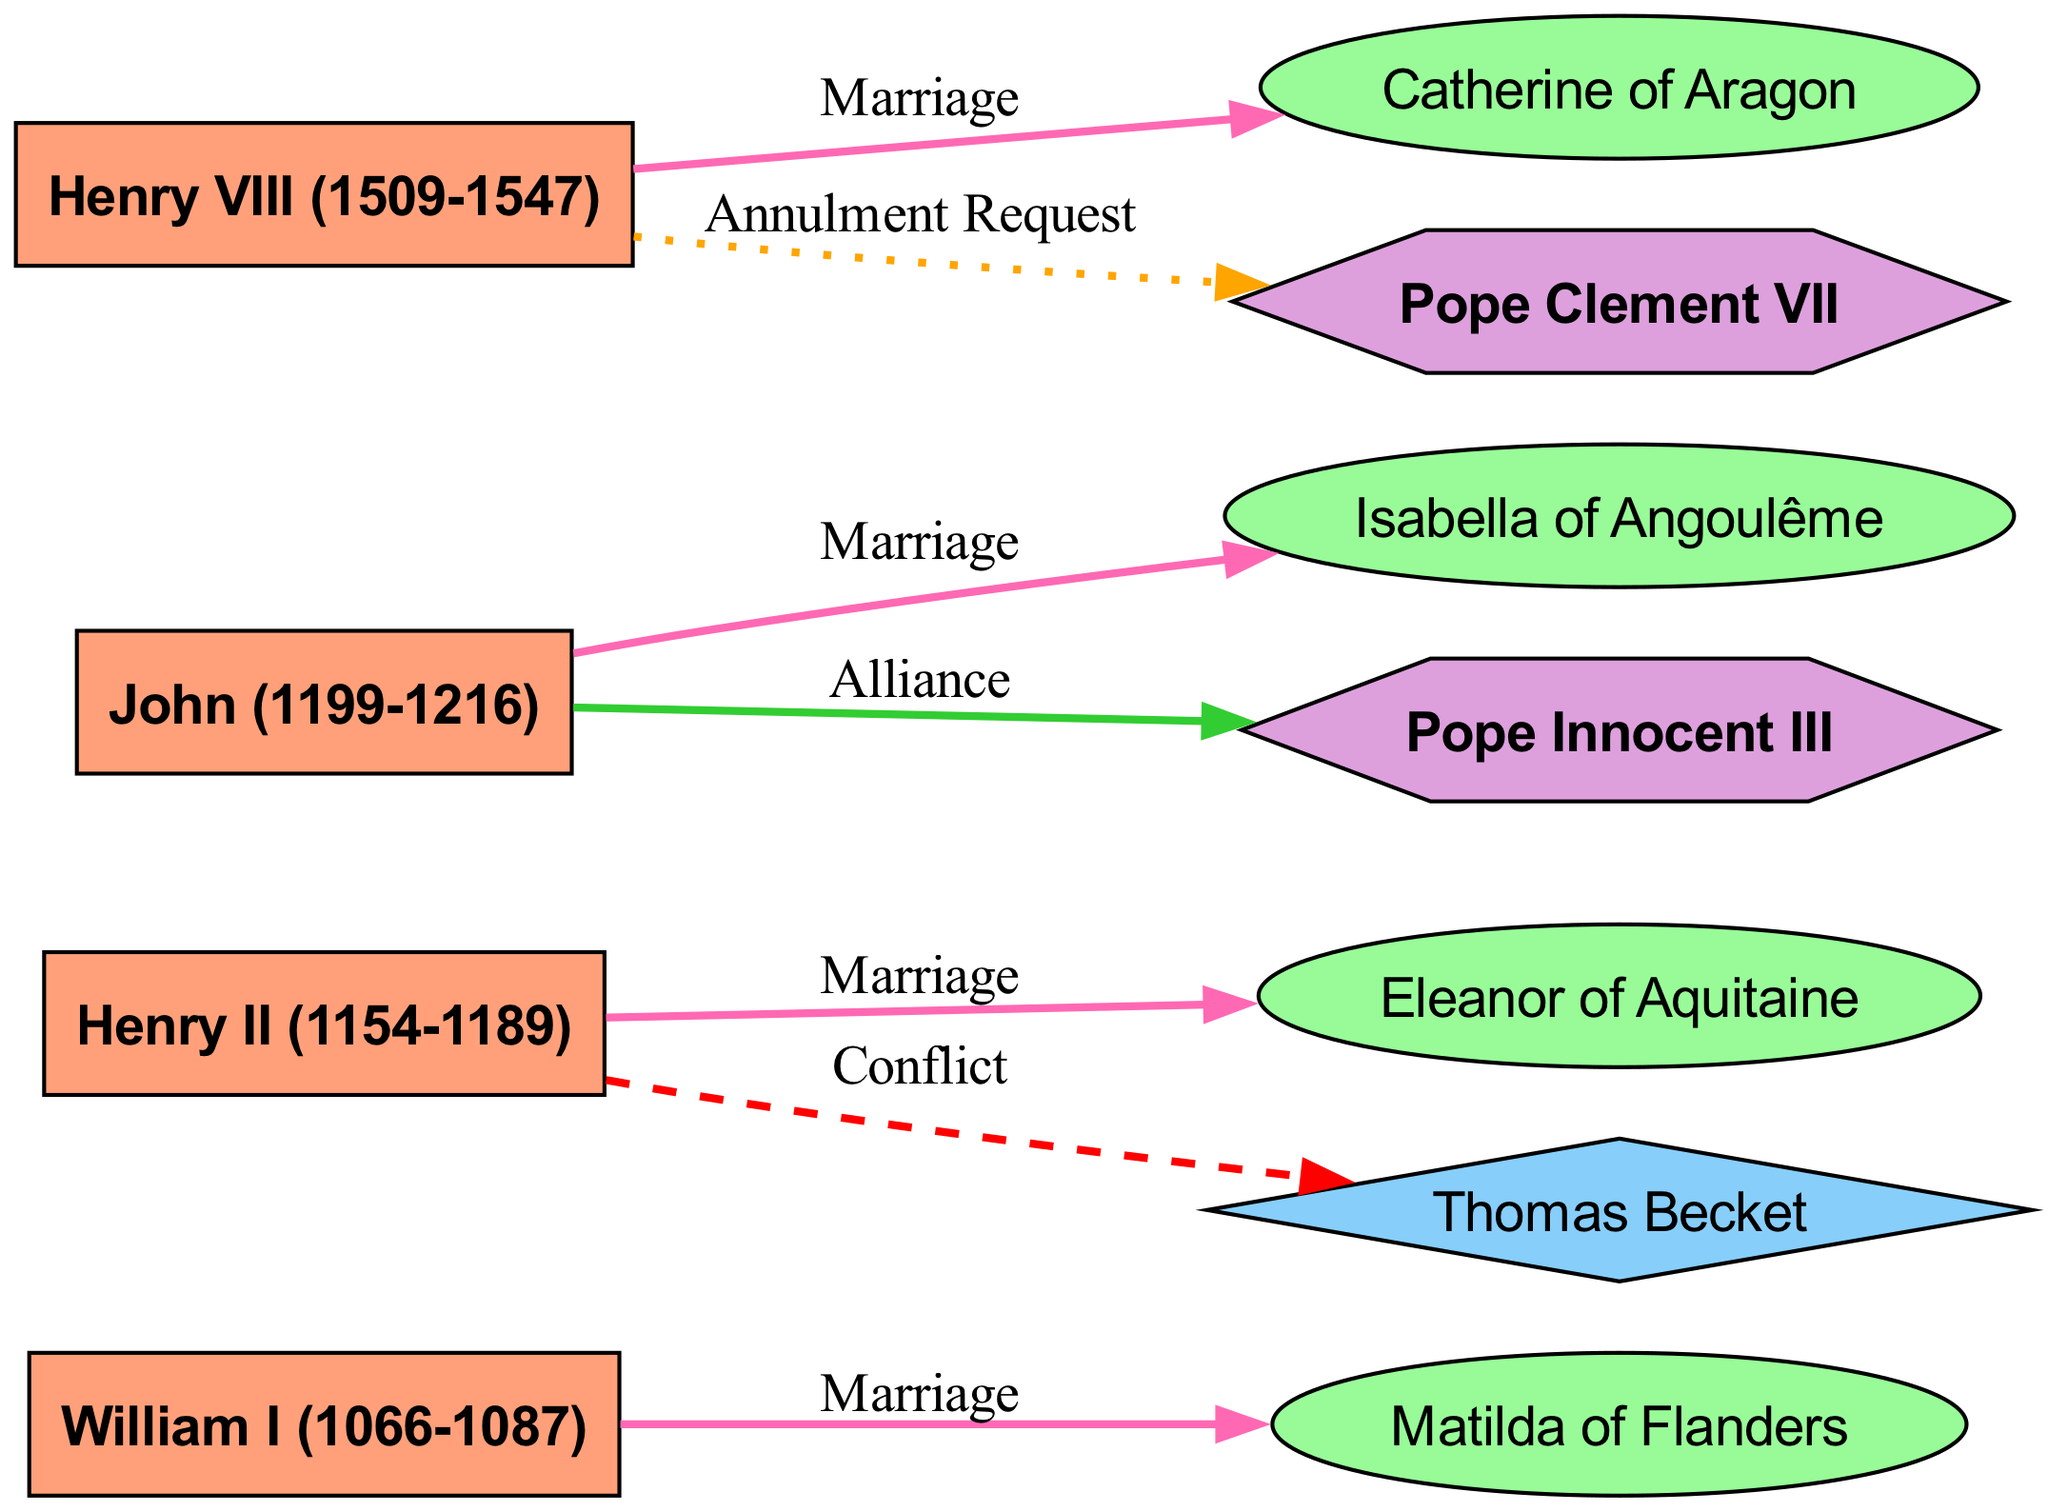What is the total number of nodes in the diagram? By counting each distinct figure represented in the diagram, we identify that there are 10 nodes which include monarchs, consorts, clergy, and popes.
Answer: 10 Who is the consort of Henry II? The diagram shows a connection labeled "Marriage" between Henry II and Eleanor of Aquitaine, indicating that she is his consort.
Answer: Eleanor of Aquitaine What type of relationship exists between John Lackland and Isabella of Angoulême? The diagram indicates a "Marriage" relationship between John Lackland and Isabella of Angoulême, which defines the connection type between these two nodes.
Answer: Marriage Which pope requested an annulment from Henry VIII? The relationship labeled "Annulment Request" points from Henry VIII to Pope Clement VII, confirming that this pope was involved in the annulment matter related to Henry VIII.
Answer: Pope Clement VII How many marriages are depicted in the diagram? By reviewing each connection labeled "Marriage", we find that there are four instances of marriages clearly stated within the diagram, confirming the number of such relationships.
Answer: 4 What is the relationship between Henry II and Thomas Becket? The diagram illustrates a "Conflict" relationship between Henry II and Thomas Becket, suggesting a notable disagreement or feud between these two historical figures.
Answer: Conflict Who had a political alliance with John Lackland? The connection labeled "Alliance" between John Lackland and Pope Innocent III demonstrates that an alliance existed between these two individuals, providing the answer.
Answer: Pope Innocent III Which monarch's consort is Catherine of Aragon? The diagram indicates a "Marriage" relationship between Henry VIII and Catherine of Aragon, making her the consort of Henry VIII.
Answer: Henry VIII What is the significance of the color used for Pope nodes in the diagram? The diagram uses a hexagon shape filled with a specific color (light purple) to represent popes, distinguishing them from monarchs, consorts, and clergy, so the color serves as a visual cue for identification.
Answer: Hexagon filled with light purple What indicates a conflict in the relationships shown? Relationships that are marked with a dashed red line in the diagram indicate a "Conflict," which is visually distinct from other types of relationships to signify tension or disagreement.
Answer: Dashed red line 